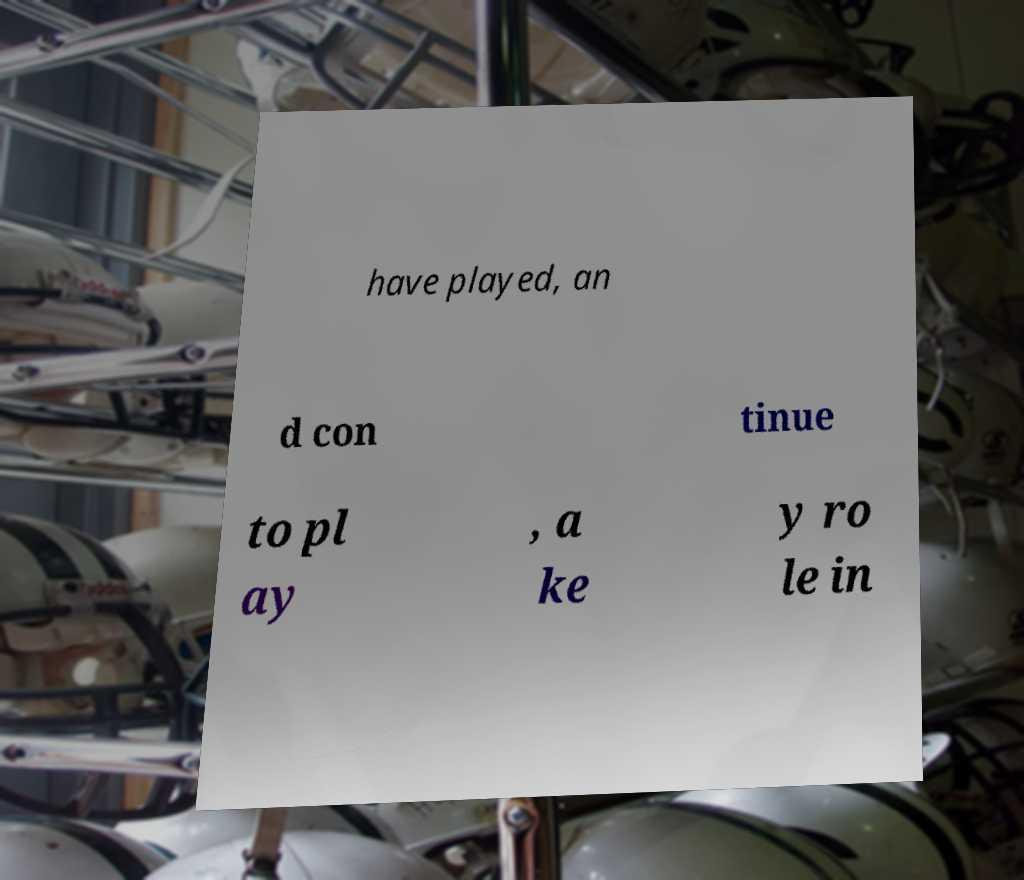Could you assist in decoding the text presented in this image and type it out clearly? have played, an d con tinue to pl ay , a ke y ro le in 